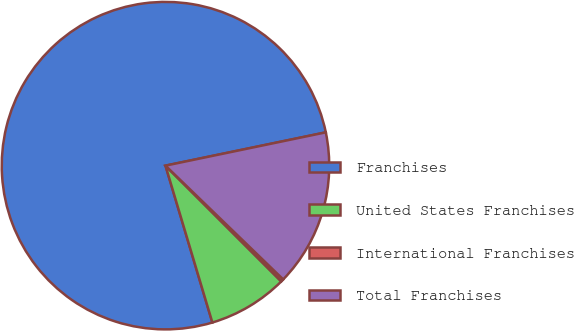Convert chart to OTSL. <chart><loc_0><loc_0><loc_500><loc_500><pie_chart><fcel>Franchises<fcel>United States Franchises<fcel>International Franchises<fcel>Total Franchises<nl><fcel>76.37%<fcel>7.88%<fcel>0.27%<fcel>15.49%<nl></chart> 